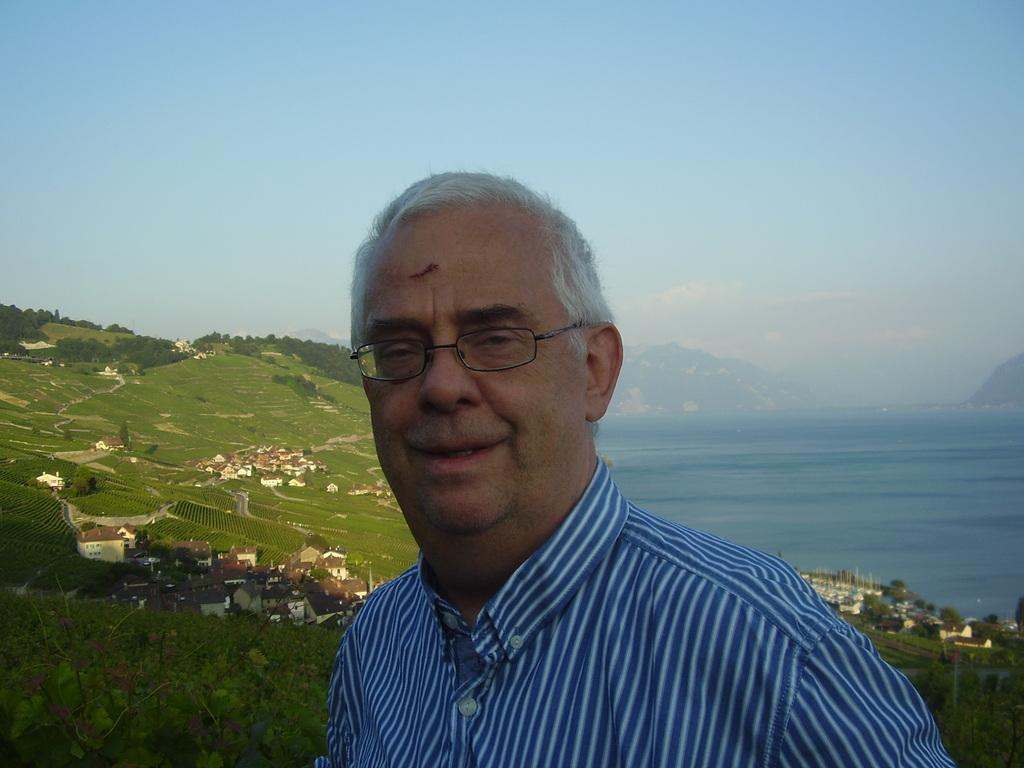What is the main subject of the image? There is a man standing in the image. Where is the man standing in relation to the mountains? The man is standing behind the mountains. What other structures can be seen in the image? There are buildings visible in the image. Can you describe the natural landscape in the image? There are mountains with trees, and there is a big river in the image. What type of juice is being served in the image? There is no juice present in the image; it features a man standing behind mountains with buildings and a river visible. 